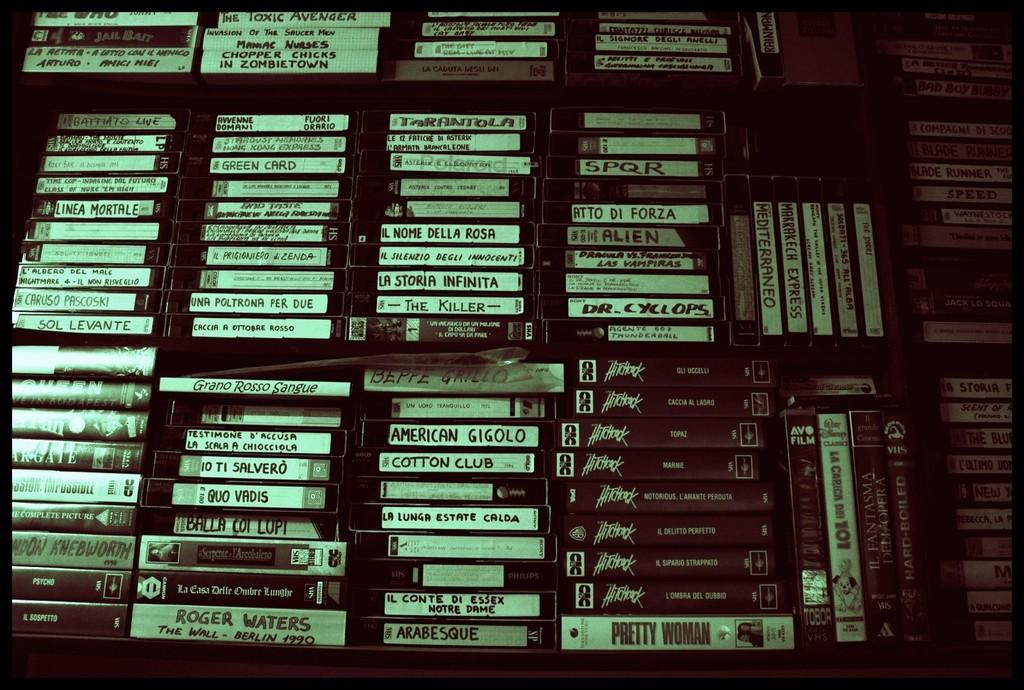<image>
Write a terse but informative summary of the picture. An assortment of VHS movies and shows including a Hitchcock series, Pretty Woman and American Gigolo. 